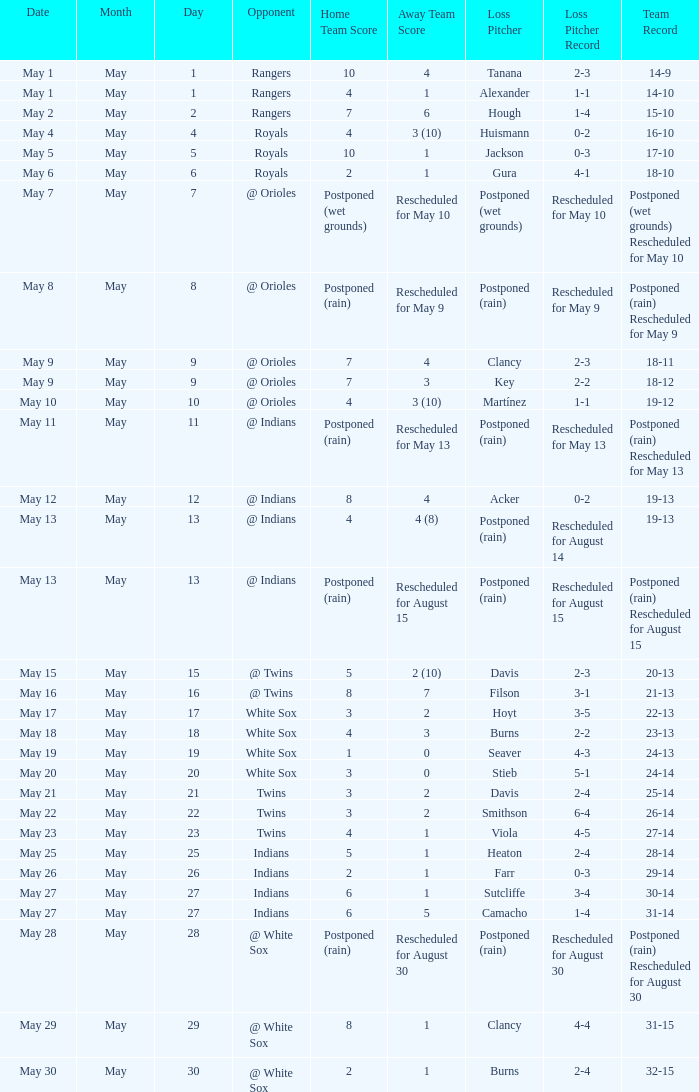What was date of the game when the record was 31-15? May 29. 